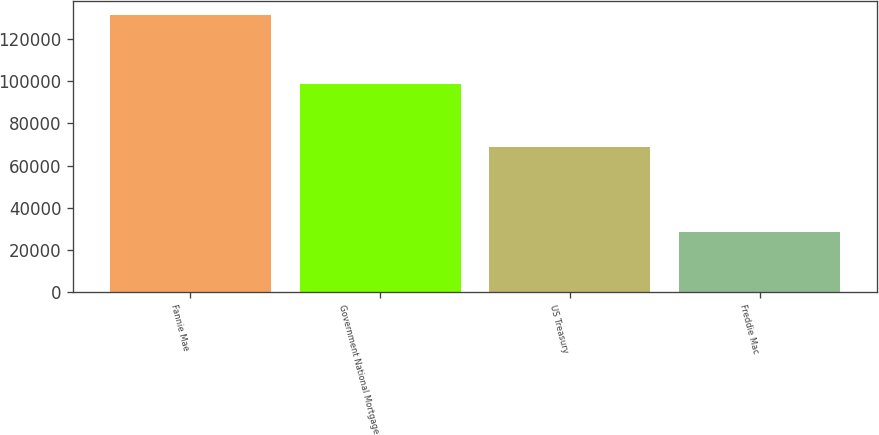Convert chart to OTSL. <chart><loc_0><loc_0><loc_500><loc_500><bar_chart><fcel>Fannie Mae<fcel>Government National Mortgage<fcel>US Treasury<fcel>Freddie Mac<nl><fcel>131418<fcel>98633<fcel>68801<fcel>28556<nl></chart> 